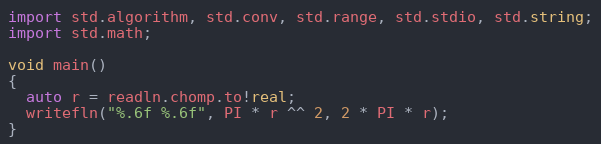Convert code to text. <code><loc_0><loc_0><loc_500><loc_500><_D_>import std.algorithm, std.conv, std.range, std.stdio, std.string;
import std.math;

void main()
{
  auto r = readln.chomp.to!real;
  writefln("%.6f %.6f", PI * r ^^ 2, 2 * PI * r);
}</code> 